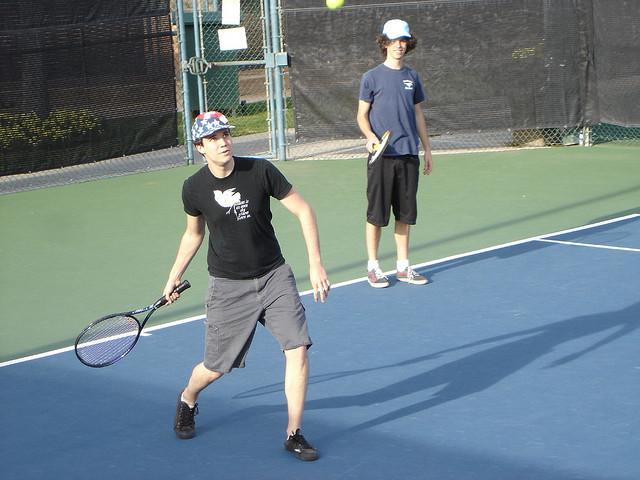What countries flag is on the man in the black shirts hat? united states 